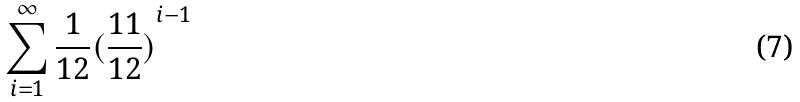Convert formula to latex. <formula><loc_0><loc_0><loc_500><loc_500>\sum _ { i = 1 } ^ { \infty } \frac { 1 } { 1 2 } { ( \frac { 1 1 } { 1 2 } ) } ^ { i - 1 }</formula> 